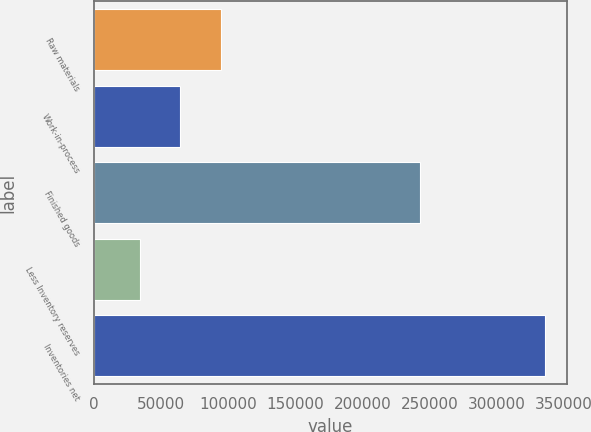<chart> <loc_0><loc_0><loc_500><loc_500><bar_chart><fcel>Raw materials<fcel>Work-in-process<fcel>Finished goods<fcel>Less Inventory reserves<fcel>Inventories net<nl><fcel>94217.8<fcel>64045.9<fcel>242750<fcel>33874<fcel>335593<nl></chart> 